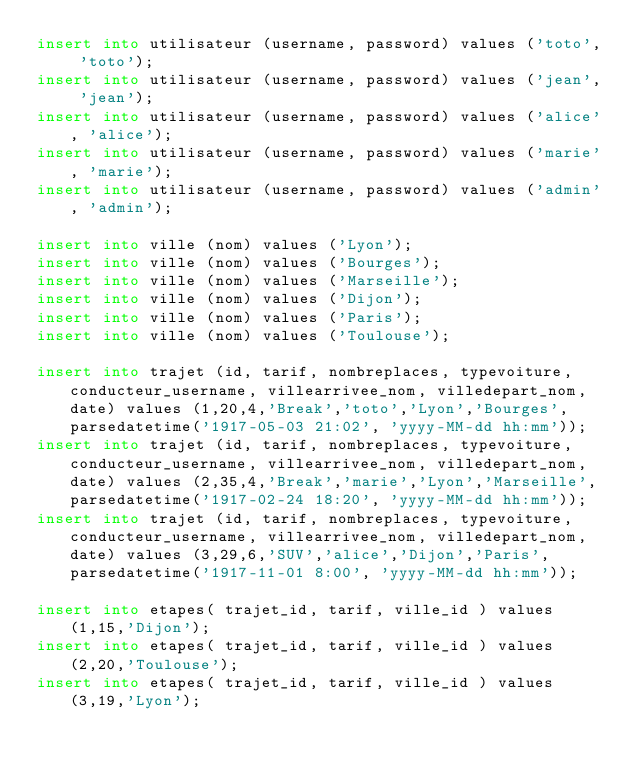<code> <loc_0><loc_0><loc_500><loc_500><_SQL_>insert into utilisateur (username, password) values ('toto', 'toto');
insert into utilisateur (username, password) values ('jean', 'jean');
insert into utilisateur (username, password) values ('alice', 'alice');
insert into utilisateur (username, password) values ('marie', 'marie');
insert into utilisateur (username, password) values ('admin', 'admin');

insert into ville (nom) values ('Lyon');
insert into ville (nom) values ('Bourges');
insert into ville (nom) values ('Marseille');
insert into ville (nom) values ('Dijon');
insert into ville (nom) values ('Paris');
insert into ville (nom) values ('Toulouse');

insert into trajet (id, tarif, nombreplaces, typevoiture, conducteur_username, villearrivee_nom, villedepart_nom, date) values (1,20,4,'Break','toto','Lyon','Bourges', parsedatetime('1917-05-03 21:02', 'yyyy-MM-dd hh:mm'));
insert into trajet (id, tarif, nombreplaces, typevoiture, conducteur_username, villearrivee_nom, villedepart_nom, date) values (2,35,4,'Break','marie','Lyon','Marseille', parsedatetime('1917-02-24 18:20', 'yyyy-MM-dd hh:mm'));
insert into trajet (id, tarif, nombreplaces, typevoiture, conducteur_username, villearrivee_nom, villedepart_nom, date) values (3,29,6,'SUV','alice','Dijon','Paris', parsedatetime('1917-11-01 8:00', 'yyyy-MM-dd hh:mm'));

insert into etapes( trajet_id, tarif, ville_id ) values(1,15,'Dijon');
insert into etapes( trajet_id, tarif, ville_id ) values(2,20,'Toulouse');
insert into etapes( trajet_id, tarif, ville_id ) values(3,19,'Lyon');
</code> 